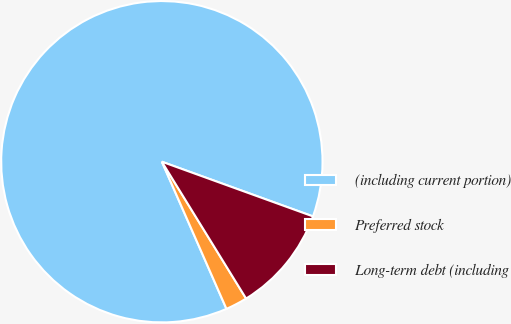<chart> <loc_0><loc_0><loc_500><loc_500><pie_chart><fcel>(including current portion)<fcel>Preferred stock<fcel>Long-term debt (including<nl><fcel>87.11%<fcel>2.2%<fcel>10.69%<nl></chart> 